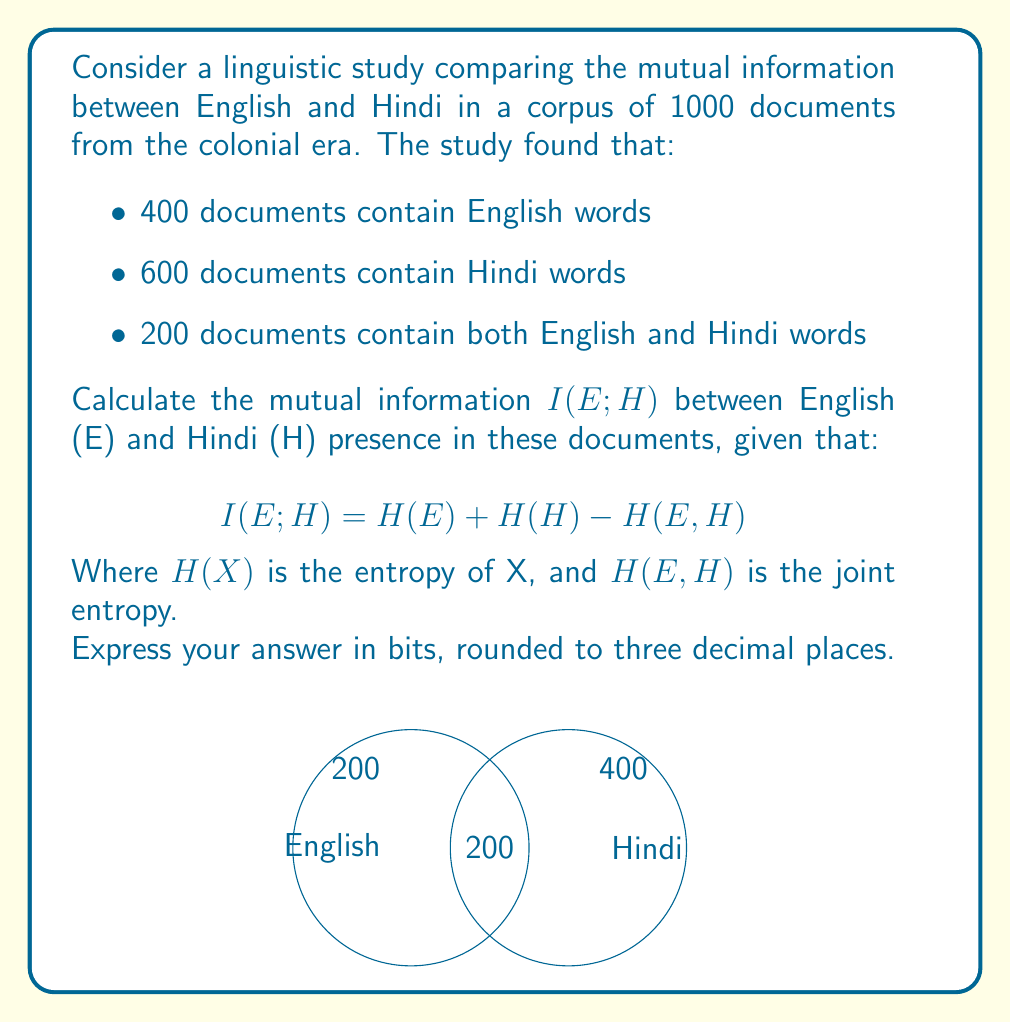Solve this math problem. To solve this problem, we need to calculate the entropies and then apply the mutual information formula. Let's proceed step-by-step:

1) First, calculate the probabilities:
   $P(E) = 400/1000 = 0.4$
   $P(H) = 600/1000 = 0.6$
   $P(E,H) = 200/1000 = 0.2$
   $P(E,\bar{H}) = 200/1000 = 0.2$
   $P(\bar{E},H) = 400/1000 = 0.4$
   $P(\bar{E},\bar{H}) = 200/1000 = 0.2$

2) Calculate $H(E)$:
   $$H(E) = -P(E)\log_2P(E) - P(\bar{E})\log_2P(\bar{E})$$
   $$= -0.4\log_2(0.4) - 0.6\log_2(0.6) = 0.971 \text{ bits}$$

3) Calculate $H(H)$:
   $$H(H) = -P(H)\log_2P(H) - P(\bar{H})\log_2P(\bar{H})$$
   $$= -0.6\log_2(0.6) - 0.4\log_2(0.4) = 0.971 \text{ bits}$$

4) Calculate $H(E,H)$:
   $$H(E,H) = -P(E,H)\log_2P(E,H) - P(E,\bar{H})\log_2P(E,\bar{H})$$
   $$- P(\bar{E},H)\log_2P(\bar{E},H) - P(\bar{E},\bar{H})\log_2P(\bar{E},\bar{H})$$
   $$= -0.2\log_2(0.2) - 0.2\log_2(0.2) - 0.4\log_2(0.4) - 0.2\log_2(0.2)$$
   $$= 1.722 \text{ bits}$$

5) Apply the mutual information formula:
   $$I(E;H) = H(E) + H(H) - H(E,H)$$
   $$= 0.971 + 0.971 - 1.722 = 0.220 \text{ bits}$$

Rounding to three decimal places gives 0.220 bits.
Answer: 0.220 bits 